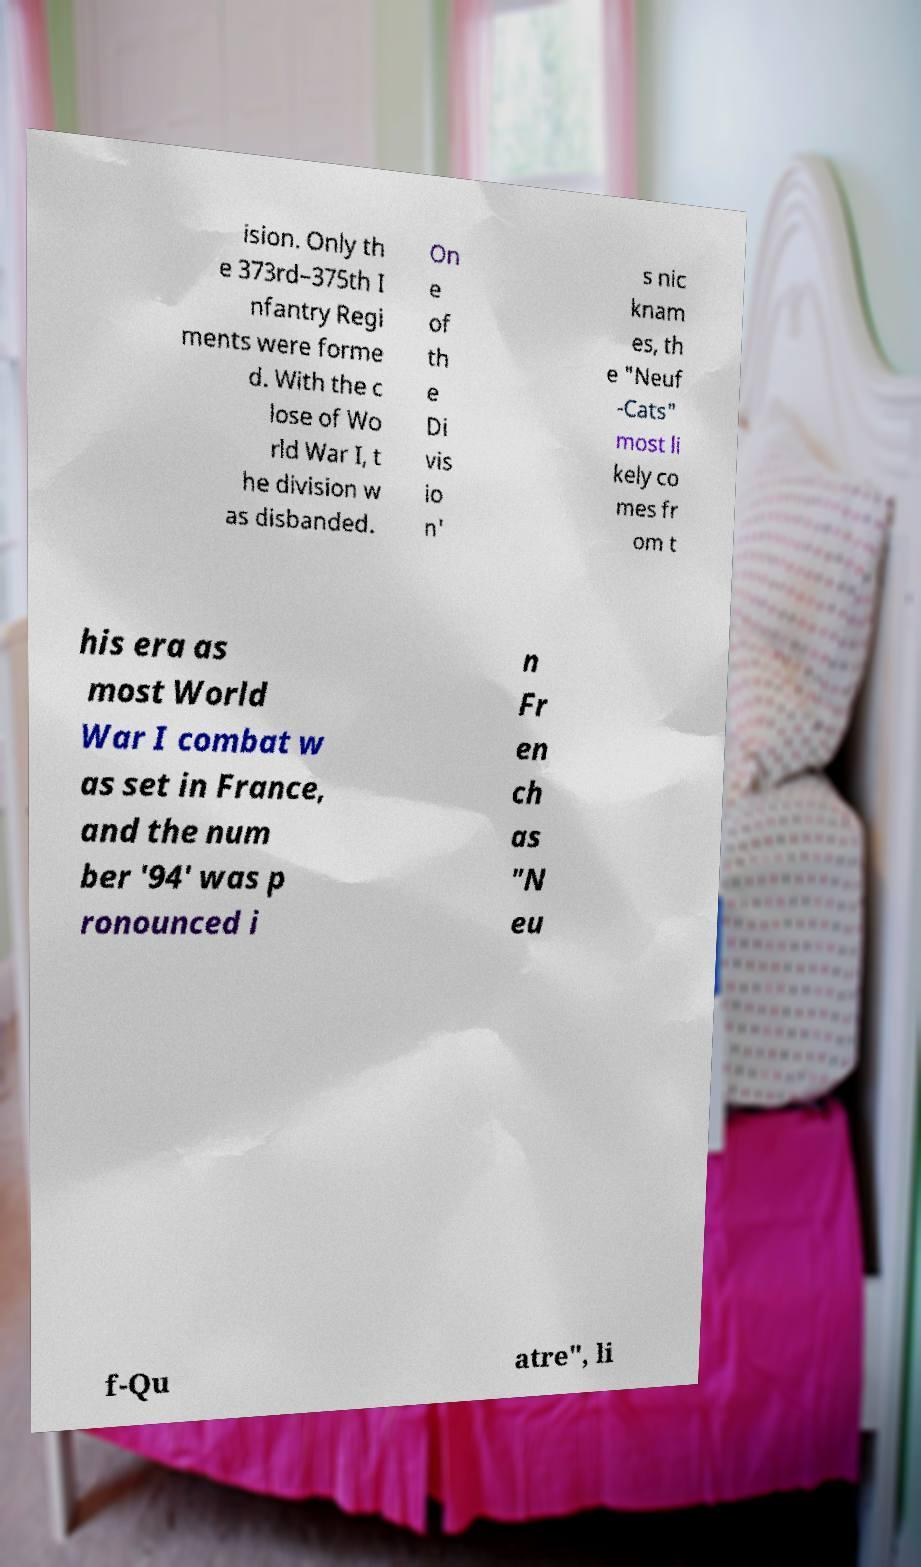I need the written content from this picture converted into text. Can you do that? ision. Only th e 373rd–375th I nfantry Regi ments were forme d. With the c lose of Wo rld War I, t he division w as disbanded. On e of th e Di vis io n' s nic knam es, th e "Neuf -Cats" most li kely co mes fr om t his era as most World War I combat w as set in France, and the num ber '94' was p ronounced i n Fr en ch as "N eu f-Qu atre", li 